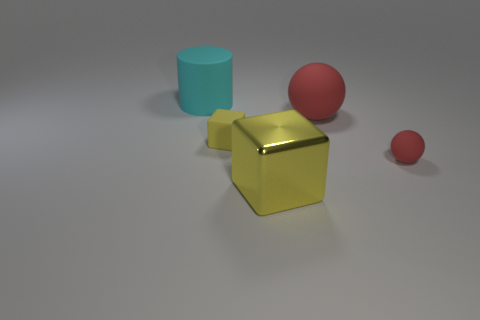What material is the small red object that is the same shape as the big red matte object? The small red object appears to be made of the same matte material as the larger red object. The matte texture suggests a non-reflective surface, which could be indicative of a rubber or possibly a plastic material with a matte finish. 